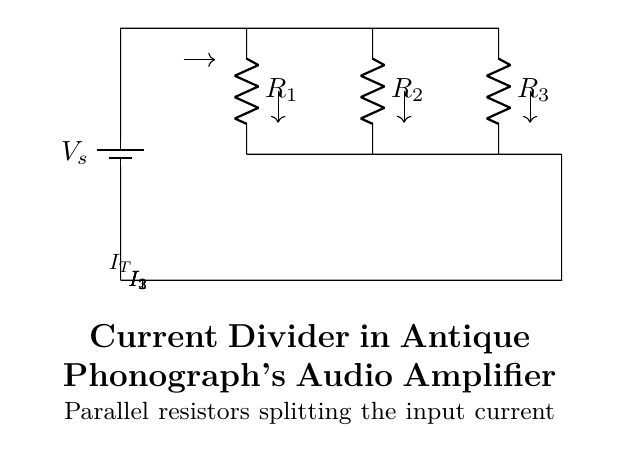What type of circuit is represented in this diagram? This is a current divider circuit, indicated by the parallel arrangement of resistors that allows total current to be divided among them.
Answer: current divider How many resistors are present in the circuit? There are three resistors (R1, R2, and R3) connected in parallel, as noted from the labels present in the diagram.
Answer: three What is the total current entering the junction? The total current entering the junction is represented by the current labeled I_T above the top node of the resistors.
Answer: I_T Which component is connected to the voltage source? The battery is connected to the circuit, providing the voltage source for the entire circuit, as indicated by the label V_s on the battery symbol.
Answer: battery What is the relationship between the currents I1, I2, and I3 in this circuit? The relationship is expressed by the current division rule, which states that the total current I_T is equal to the sum of the individual branch currents I1, I2, and I3. Therefore, I_T = I1 + I2 + I3.
Answer: I_T = I1 + I2 + I3 How does the resistance value affect the current through R2? According to the current divider principle, if R2 has a lower resistance value compared to R1 and R3, then a larger proportion of I_T will flow through R2. Conversely, a higher resistance would lead to less current through R2.
Answer: Inversely proportional What is the role of parallel resistors in this audio amplifier circuit? The parallel resistors in the audio amplifier circuit allow for current division, which helps in controlling how much current flows to different parts of the amplifier, impacting audio signal quality and amplification stability.
Answer: current control 